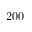<formula> <loc_0><loc_0><loc_500><loc_500>2 0 0</formula> 